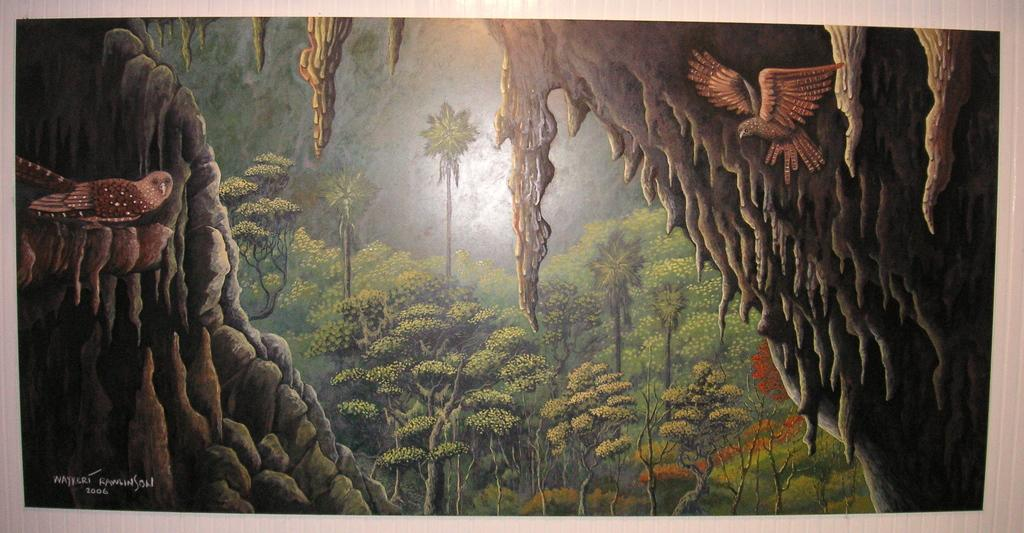What type of object is the image depicting? The image appears to be a photo frame. What can be seen inside the photo frame? There is a bird in the image. What type of natural environment is visible in the image? There are trees, grass, and stones in the image. Is there any text present in the image? Yes, there is text in the image. What is the chance of winning a vacation in the image? There is no mention of a vacation or winning in the image. 